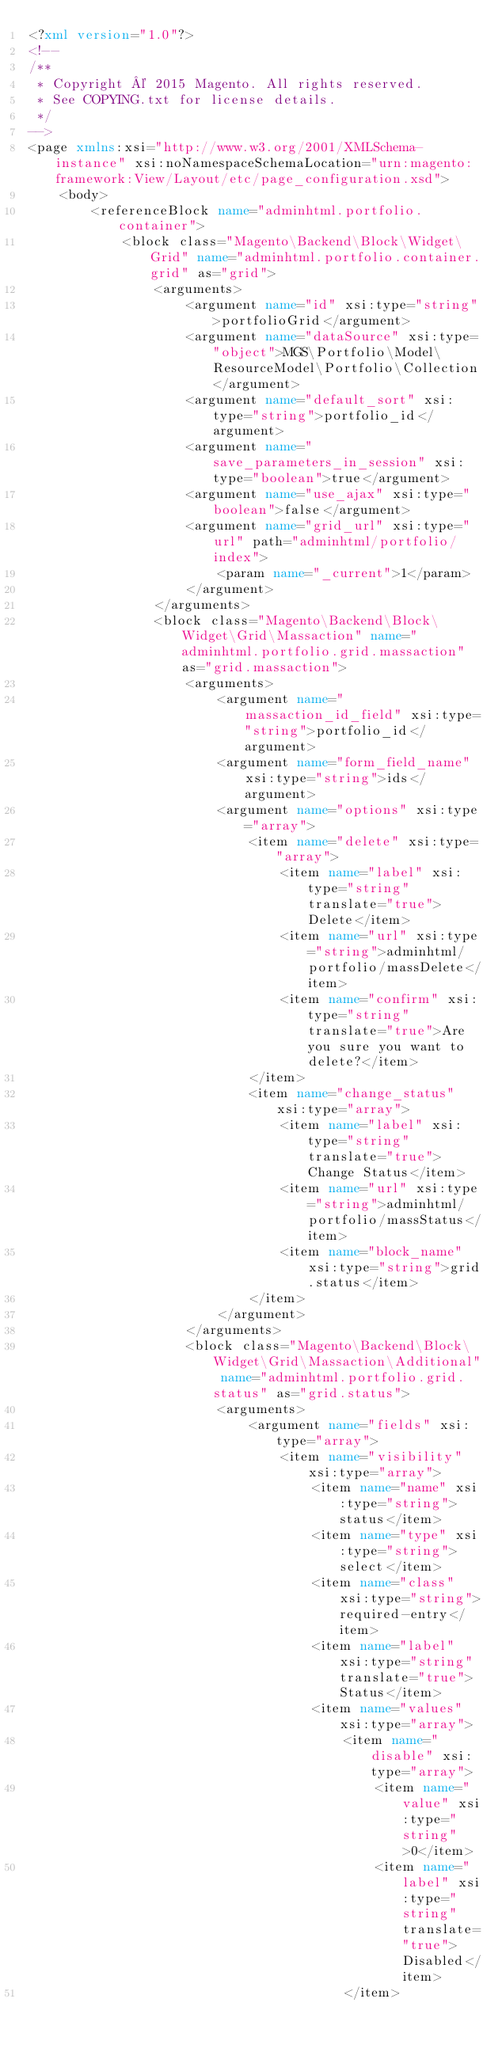Convert code to text. <code><loc_0><loc_0><loc_500><loc_500><_XML_><?xml version="1.0"?>
<!--
/**
 * Copyright © 2015 Magento. All rights reserved.
 * See COPYING.txt for license details.
 */
-->
<page xmlns:xsi="http://www.w3.org/2001/XMLSchema-instance" xsi:noNamespaceSchemaLocation="urn:magento:framework:View/Layout/etc/page_configuration.xsd">
    <body>
        <referenceBlock name="adminhtml.portfolio.container">
            <block class="Magento\Backend\Block\Widget\Grid" name="adminhtml.portfolio.container.grid" as="grid">
				<arguments>
					<argument name="id" xsi:type="string">portfolioGrid</argument>
					<argument name="dataSource" xsi:type="object">MGS\Portfolio\Model\ResourceModel\Portfolio\Collection</argument>
					<argument name="default_sort" xsi:type="string">portfolio_id</argument>
					<argument name="save_parameters_in_session" xsi:type="boolean">true</argument>
					<argument name="use_ajax" xsi:type="boolean">false</argument>
					<argument name="grid_url" xsi:type="url" path="adminhtml/portfolio/index">
						<param name="_current">1</param>
					</argument>
				</arguments>
				<block class="Magento\Backend\Block\Widget\Grid\Massaction" name="adminhtml.portfolio.grid.massaction" as="grid.massaction">
					<arguments>
						<argument name="massaction_id_field" xsi:type="string">portfolio_id</argument>
						<argument name="form_field_name" xsi:type="string">ids</argument>
						<argument name="options" xsi:type="array">
							<item name="delete" xsi:type="array">
								<item name="label" xsi:type="string" translate="true">Delete</item>
								<item name="url" xsi:type="string">adminhtml/portfolio/massDelete</item>
								<item name="confirm" xsi:type="string" translate="true">Are you sure you want to delete?</item>
							</item>
							<item name="change_status" xsi:type="array">
								<item name="label" xsi:type="string" translate="true">Change Status</item>
								<item name="url" xsi:type="string">adminhtml/portfolio/massStatus</item>
								<item name="block_name" xsi:type="string">grid.status</item>
							</item>
						</argument>
					</arguments>
					<block class="Magento\Backend\Block\Widget\Grid\Massaction\Additional" name="adminhtml.portfolio.grid.status" as="grid.status">
						<arguments>
							<argument name="fields" xsi:type="array">
								<item name="visibility" xsi:type="array">
									<item name="name" xsi:type="string">status</item>
									<item name="type" xsi:type="string">select</item>
									<item name="class" xsi:type="string">required-entry</item>
									<item name="label" xsi:type="string" translate="true">Status</item>
									<item name="values" xsi:type="array">
										<item name="disable" xsi:type="array">
											<item name="value" xsi:type="string">0</item>
											<item name="label" xsi:type="string" translate="true">Disabled</item>
										</item></code> 